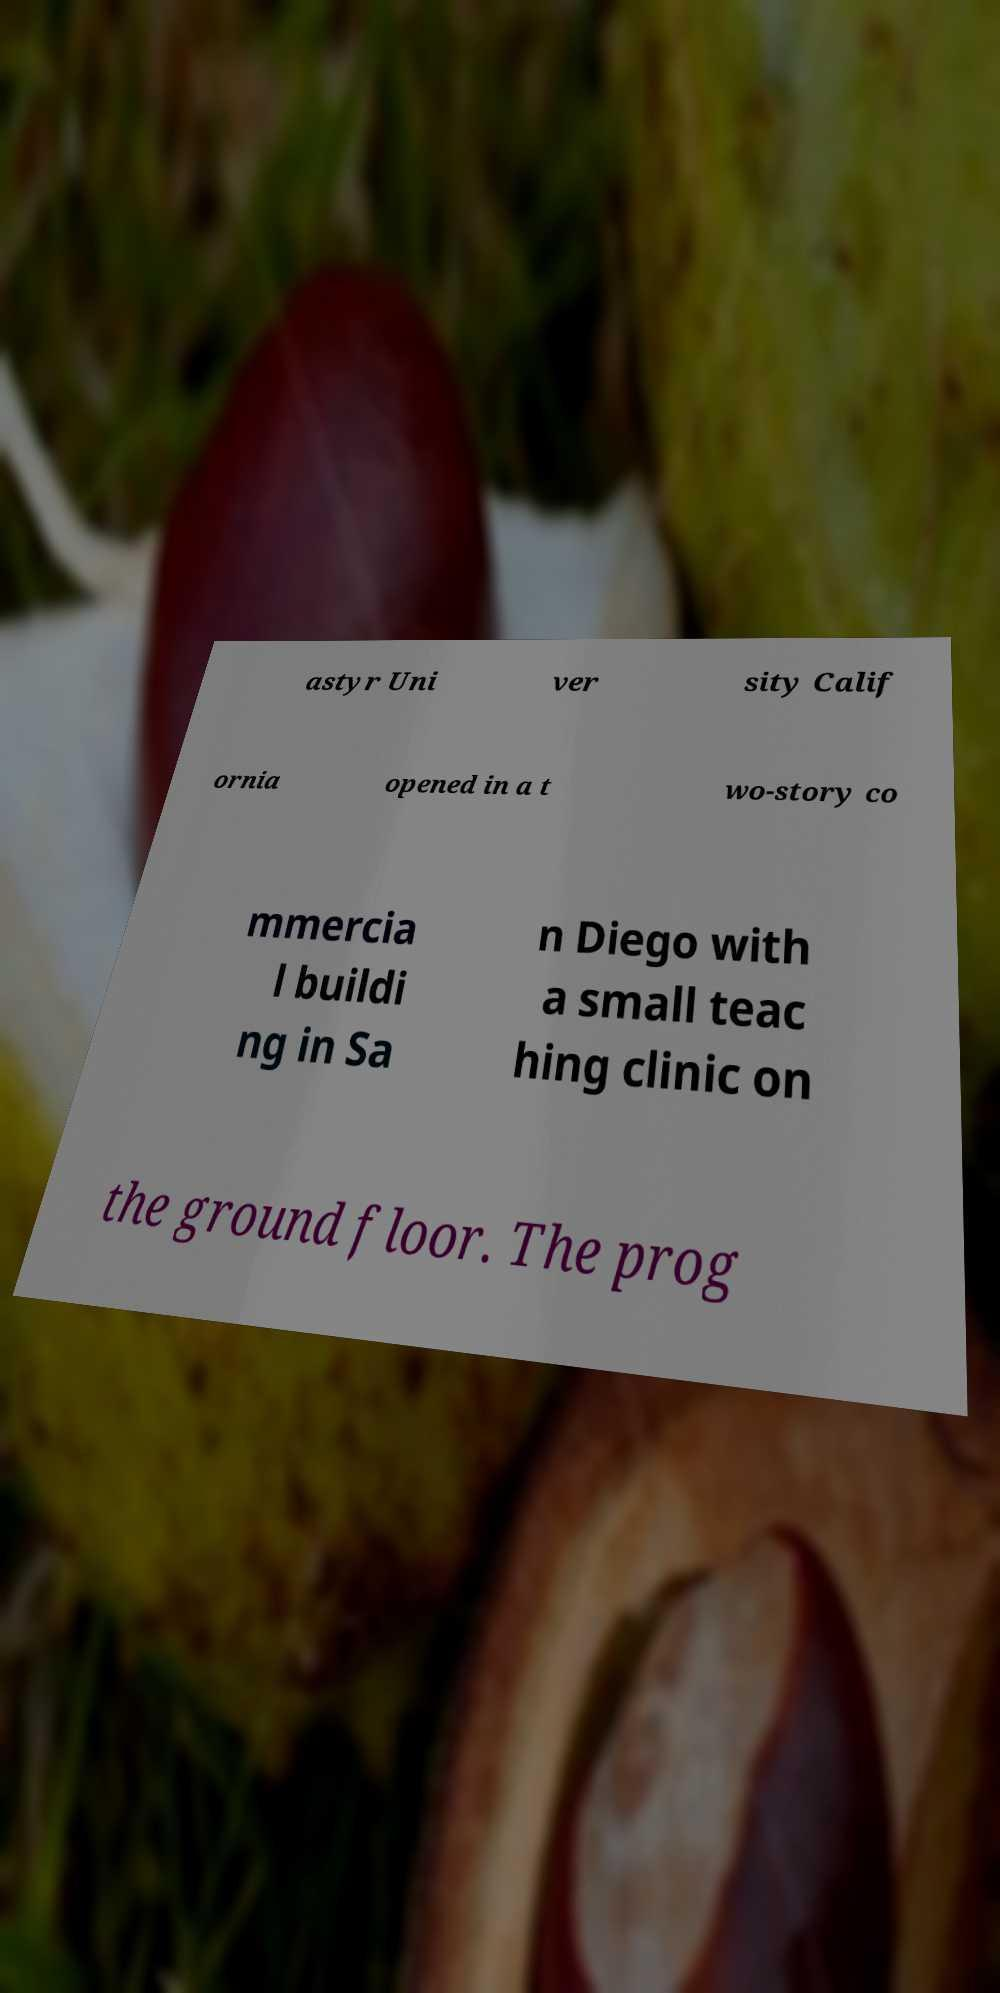I need the written content from this picture converted into text. Can you do that? astyr Uni ver sity Calif ornia opened in a t wo-story co mmercia l buildi ng in Sa n Diego with a small teac hing clinic on the ground floor. The prog 